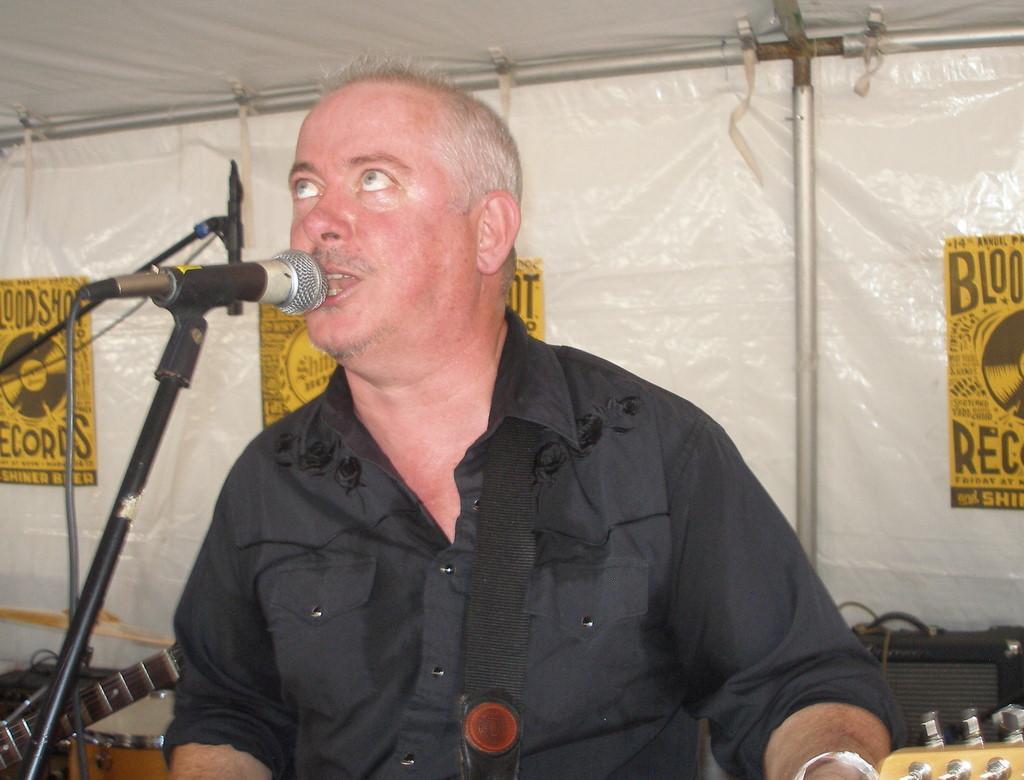Describe this image in one or two sentences. In the image we can see a man wearing black clothes and he is talking. In front of him there is a microphone and these are the cable wires. We can see there are even musical instruments, posters and a pole tent. 